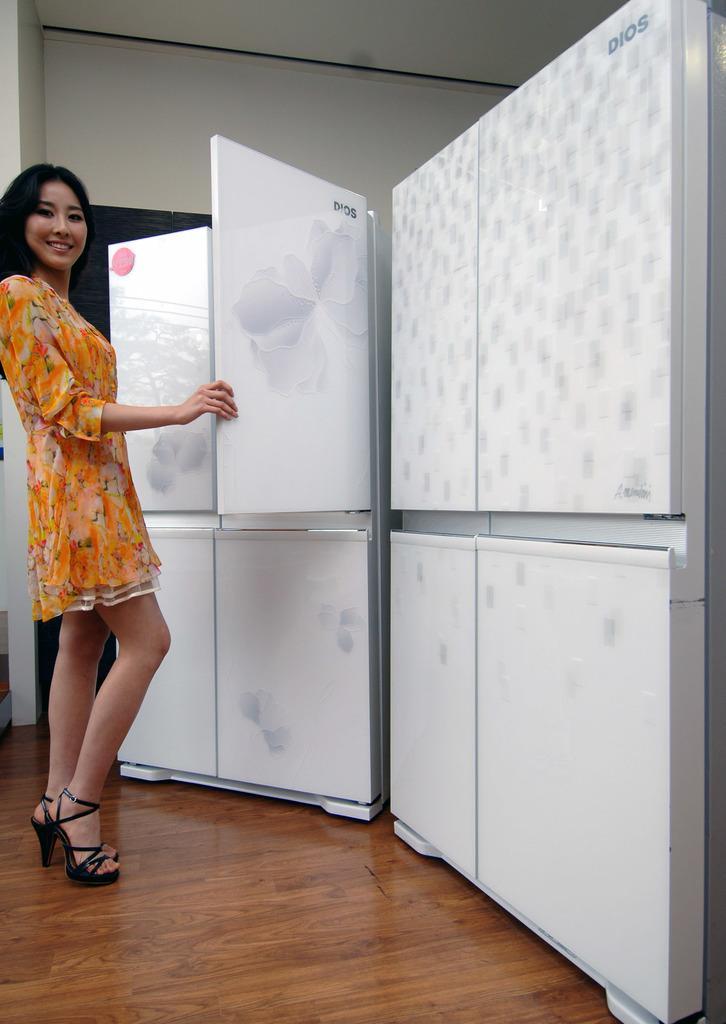What does it say on the top of the first panel?
Your answer should be compact. Dios. 